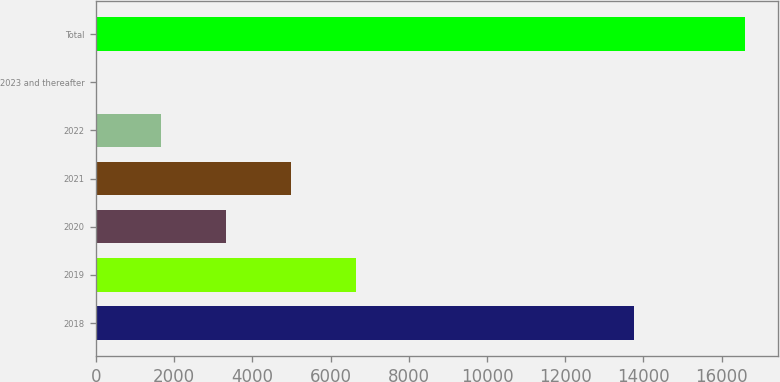<chart> <loc_0><loc_0><loc_500><loc_500><bar_chart><fcel>2018<fcel>2019<fcel>2020<fcel>2021<fcel>2022<fcel>2023 and thereafter<fcel>Total<nl><fcel>13754<fcel>6646.6<fcel>3325.8<fcel>4986.2<fcel>1665.4<fcel>5<fcel>16609<nl></chart> 